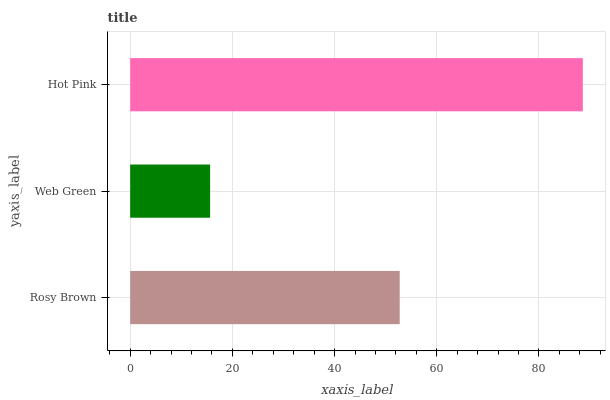Is Web Green the minimum?
Answer yes or no. Yes. Is Hot Pink the maximum?
Answer yes or no. Yes. Is Hot Pink the minimum?
Answer yes or no. No. Is Web Green the maximum?
Answer yes or no. No. Is Hot Pink greater than Web Green?
Answer yes or no. Yes. Is Web Green less than Hot Pink?
Answer yes or no. Yes. Is Web Green greater than Hot Pink?
Answer yes or no. No. Is Hot Pink less than Web Green?
Answer yes or no. No. Is Rosy Brown the high median?
Answer yes or no. Yes. Is Rosy Brown the low median?
Answer yes or no. Yes. Is Web Green the high median?
Answer yes or no. No. Is Web Green the low median?
Answer yes or no. No. 